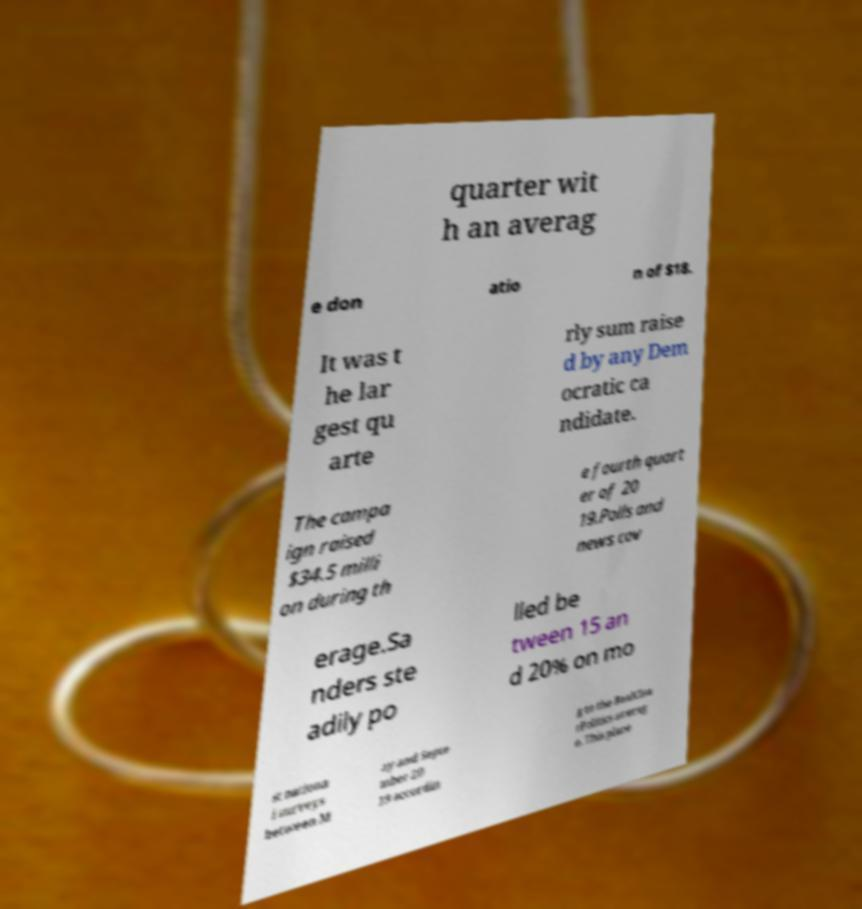Could you assist in decoding the text presented in this image and type it out clearly? quarter wit h an averag e don atio n of $18. It was t he lar gest qu arte rly sum raise d by any Dem ocratic ca ndidate. The campa ign raised $34.5 milli on during th e fourth quart er of 20 19.Polls and news cov erage.Sa nders ste adily po lled be tween 15 an d 20% on mo st nationa l surveys between M ay and Septe mber 20 19 accordin g to the RealClea rPolitics averag e. This place 